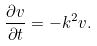<formula> <loc_0><loc_0><loc_500><loc_500>\frac { \partial v } { \partial t } = - k ^ { 2 } v .</formula> 